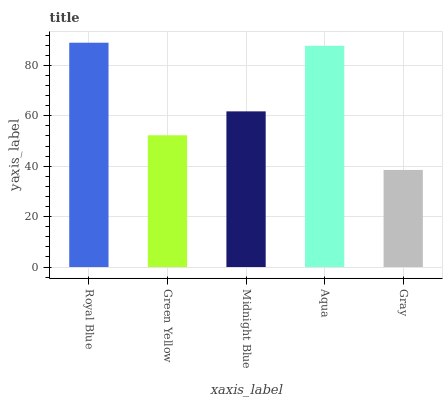Is Green Yellow the minimum?
Answer yes or no. No. Is Green Yellow the maximum?
Answer yes or no. No. Is Royal Blue greater than Green Yellow?
Answer yes or no. Yes. Is Green Yellow less than Royal Blue?
Answer yes or no. Yes. Is Green Yellow greater than Royal Blue?
Answer yes or no. No. Is Royal Blue less than Green Yellow?
Answer yes or no. No. Is Midnight Blue the high median?
Answer yes or no. Yes. Is Midnight Blue the low median?
Answer yes or no. Yes. Is Aqua the high median?
Answer yes or no. No. Is Gray the low median?
Answer yes or no. No. 